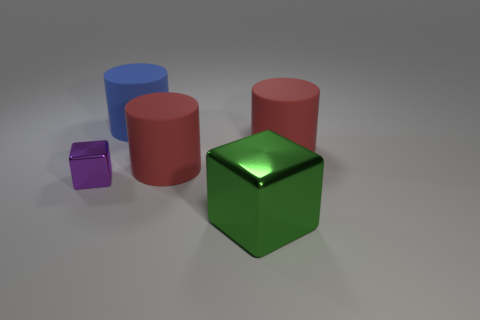Is the tiny metal thing the same color as the big block?
Keep it short and to the point. No. Is there a blue matte cylinder to the right of the red rubber thing right of the big object in front of the small purple shiny thing?
Keep it short and to the point. No. How many shiny things are the same size as the purple shiny block?
Your answer should be compact. 0. There is a metal block in front of the purple object; is its size the same as the red rubber thing that is to the left of the green metal block?
Keep it short and to the point. Yes. There is a large rubber object that is both to the right of the large blue matte cylinder and to the left of the green metallic cube; what shape is it?
Your response must be concise. Cylinder. Is there a large rubber thing that has the same color as the tiny block?
Give a very brief answer. No. Are any large cyan shiny things visible?
Your answer should be compact. No. There is a cube right of the purple cube; what color is it?
Make the answer very short. Green. Do the green block and the cube to the left of the big blue cylinder have the same size?
Offer a very short reply. No. What is the size of the cylinder that is both on the left side of the big shiny thing and to the right of the large blue matte thing?
Give a very brief answer. Large. 